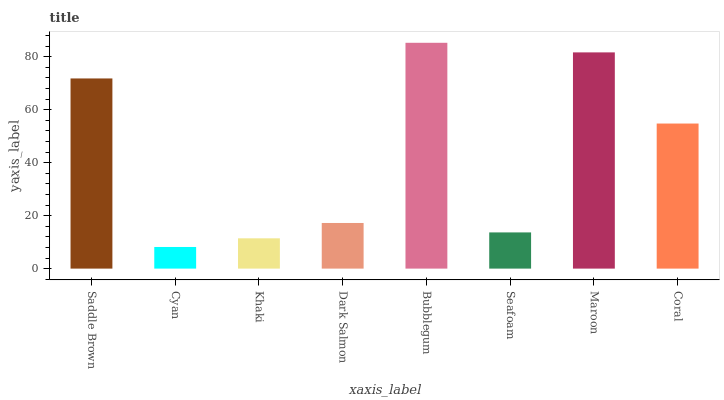Is Cyan the minimum?
Answer yes or no. Yes. Is Bubblegum the maximum?
Answer yes or no. Yes. Is Khaki the minimum?
Answer yes or no. No. Is Khaki the maximum?
Answer yes or no. No. Is Khaki greater than Cyan?
Answer yes or no. Yes. Is Cyan less than Khaki?
Answer yes or no. Yes. Is Cyan greater than Khaki?
Answer yes or no. No. Is Khaki less than Cyan?
Answer yes or no. No. Is Coral the high median?
Answer yes or no. Yes. Is Dark Salmon the low median?
Answer yes or no. Yes. Is Dark Salmon the high median?
Answer yes or no. No. Is Cyan the low median?
Answer yes or no. No. 